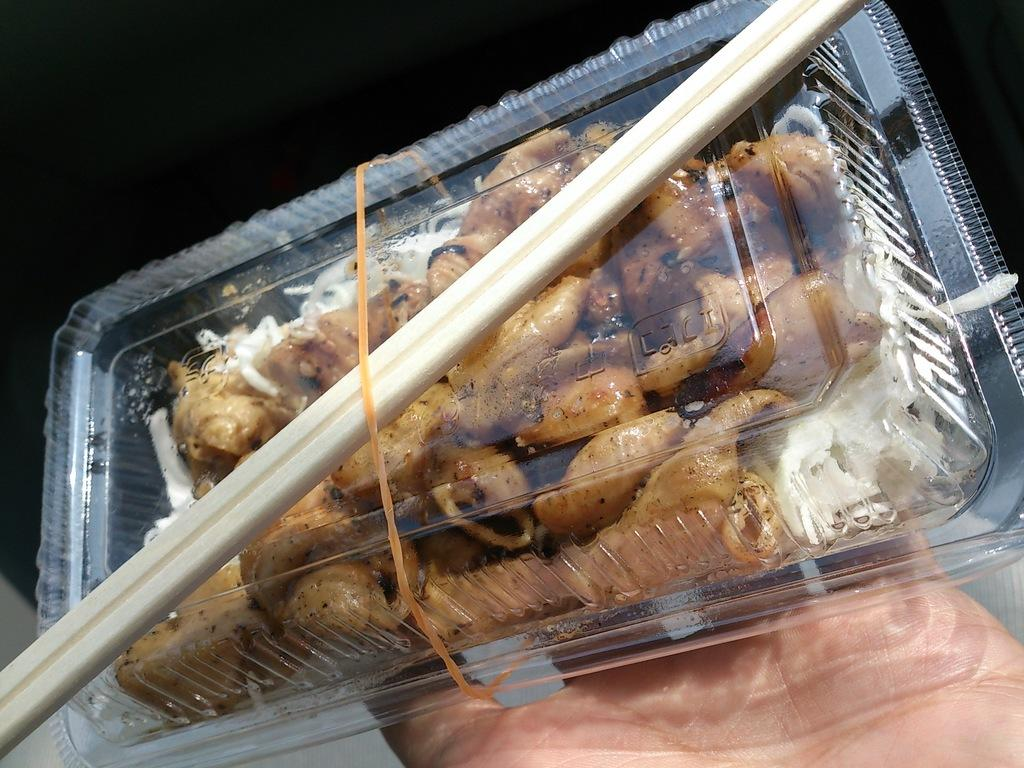What is being held by the person's hand in the image? There is a person's hand holding a box in the image. What is inside the box that is being held? The box contains food. What utensil is placed on top of the box? There are chopsticks on top of the box. What type of locket is hanging from the person's knee in the image? There is no locket or person's knee present in the image; it only shows a hand holding a box with food and chopsticks on top. 